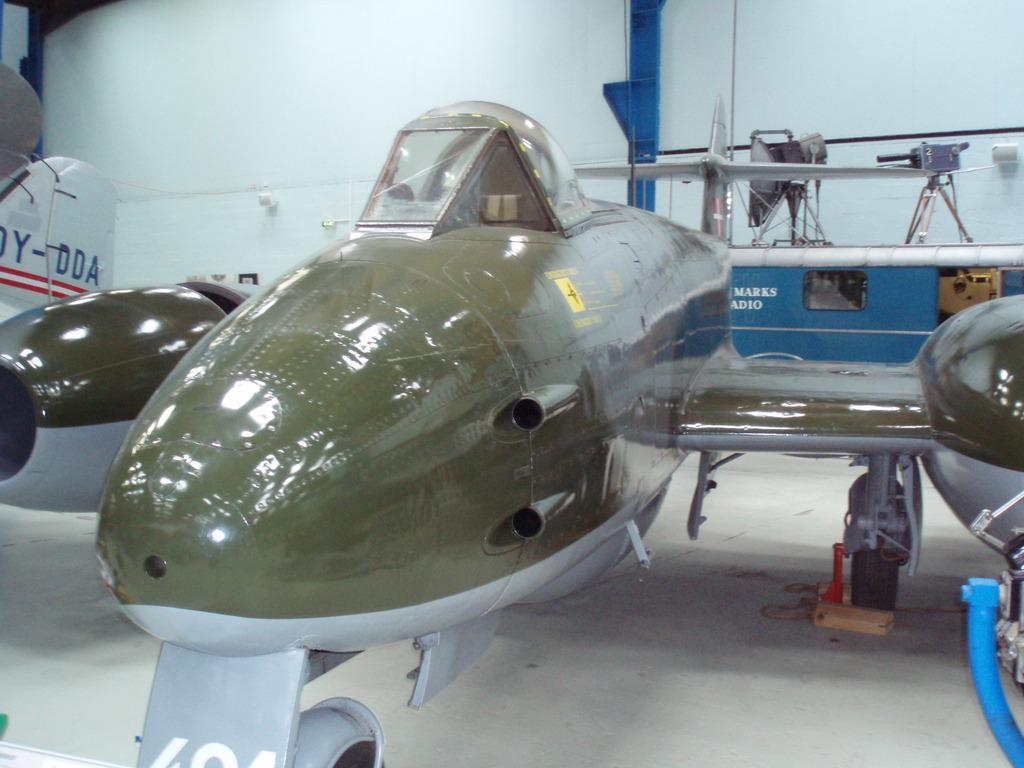<image>
Give a short and clear explanation of the subsequent image. A green airplane sits next to a plane that has DDA on the side of it. 